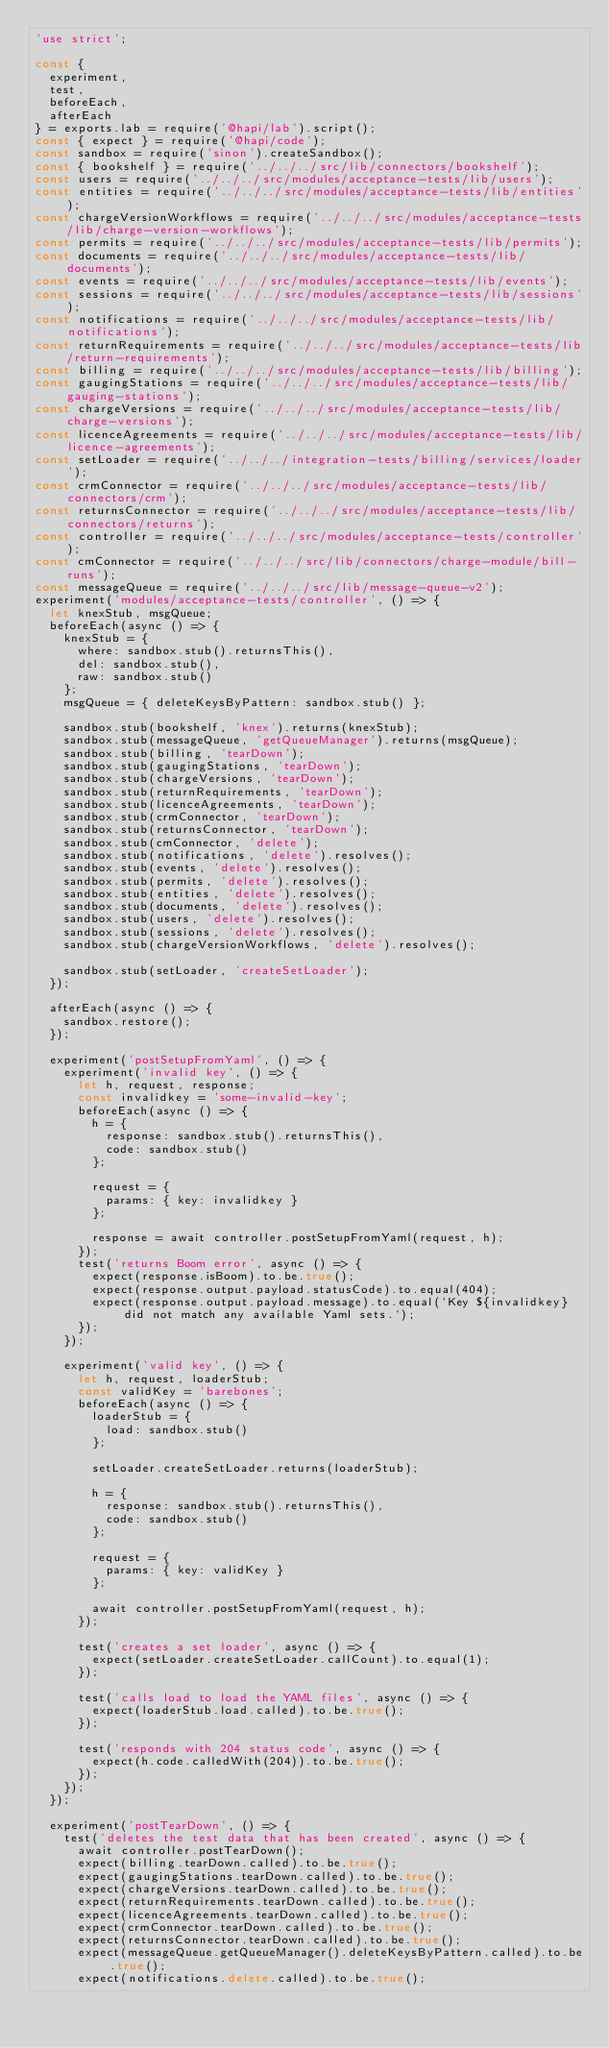Convert code to text. <code><loc_0><loc_0><loc_500><loc_500><_JavaScript_>'use strict';

const {
  experiment,
  test,
  beforeEach,
  afterEach
} = exports.lab = require('@hapi/lab').script();
const { expect } = require('@hapi/code');
const sandbox = require('sinon').createSandbox();
const { bookshelf } = require('../../../src/lib/connectors/bookshelf');
const users = require('../../../src/modules/acceptance-tests/lib/users');
const entities = require('../../../src/modules/acceptance-tests/lib/entities');
const chargeVersionWorkflows = require('../../../src/modules/acceptance-tests/lib/charge-version-workflows');
const permits = require('../../../src/modules/acceptance-tests/lib/permits');
const documents = require('../../../src/modules/acceptance-tests/lib/documents');
const events = require('../../../src/modules/acceptance-tests/lib/events');
const sessions = require('../../../src/modules/acceptance-tests/lib/sessions');
const notifications = require('../../../src/modules/acceptance-tests/lib/notifications');
const returnRequirements = require('../../../src/modules/acceptance-tests/lib/return-requirements');
const billing = require('../../../src/modules/acceptance-tests/lib/billing');
const gaugingStations = require('../../../src/modules/acceptance-tests/lib/gauging-stations');
const chargeVersions = require('../../../src/modules/acceptance-tests/lib/charge-versions');
const licenceAgreements = require('../../../src/modules/acceptance-tests/lib/licence-agreements');
const setLoader = require('../../../integration-tests/billing/services/loader');
const crmConnector = require('../../../src/modules/acceptance-tests/lib/connectors/crm');
const returnsConnector = require('../../../src/modules/acceptance-tests/lib/connectors/returns');
const controller = require('../../../src/modules/acceptance-tests/controller');
const cmConnector = require('../../../src/lib/connectors/charge-module/bill-runs');
const messageQueue = require('../../../src/lib/message-queue-v2');
experiment('modules/acceptance-tests/controller', () => {
  let knexStub, msgQueue;
  beforeEach(async () => {
    knexStub = {
      where: sandbox.stub().returnsThis(),
      del: sandbox.stub(),
      raw: sandbox.stub()
    };
    msgQueue = { deleteKeysByPattern: sandbox.stub() };

    sandbox.stub(bookshelf, 'knex').returns(knexStub);
    sandbox.stub(messageQueue, 'getQueueManager').returns(msgQueue);
    sandbox.stub(billing, 'tearDown');
    sandbox.stub(gaugingStations, 'tearDown');
    sandbox.stub(chargeVersions, 'tearDown');
    sandbox.stub(returnRequirements, 'tearDown');
    sandbox.stub(licenceAgreements, 'tearDown');
    sandbox.stub(crmConnector, 'tearDown');
    sandbox.stub(returnsConnector, 'tearDown');
    sandbox.stub(cmConnector, 'delete');
    sandbox.stub(notifications, 'delete').resolves();
    sandbox.stub(events, 'delete').resolves();
    sandbox.stub(permits, 'delete').resolves();
    sandbox.stub(entities, 'delete').resolves();
    sandbox.stub(documents, 'delete').resolves();
    sandbox.stub(users, 'delete').resolves();
    sandbox.stub(sessions, 'delete').resolves();
    sandbox.stub(chargeVersionWorkflows, 'delete').resolves();

    sandbox.stub(setLoader, 'createSetLoader');
  });

  afterEach(async () => {
    sandbox.restore();
  });

  experiment('postSetupFromYaml', () => {
    experiment('invalid key', () => {
      let h, request, response;
      const invalidkey = 'some-invalid-key';
      beforeEach(async () => {
        h = {
          response: sandbox.stub().returnsThis(),
          code: sandbox.stub()
        };

        request = {
          params: { key: invalidkey }
        };

        response = await controller.postSetupFromYaml(request, h);
      });
      test('returns Boom error', async () => {
        expect(response.isBoom).to.be.true();
        expect(response.output.payload.statusCode).to.equal(404);
        expect(response.output.payload.message).to.equal(`Key ${invalidkey} did not match any available Yaml sets.`);
      });
    });

    experiment('valid key', () => {
      let h, request, loaderStub;
      const validKey = 'barebones';
      beforeEach(async () => {
        loaderStub = {
          load: sandbox.stub()
        };

        setLoader.createSetLoader.returns(loaderStub);

        h = {
          response: sandbox.stub().returnsThis(),
          code: sandbox.stub()
        };

        request = {
          params: { key: validKey }
        };

        await controller.postSetupFromYaml(request, h);
      });

      test('creates a set loader', async () => {
        expect(setLoader.createSetLoader.callCount).to.equal(1);
      });

      test('calls load to load the YAML files', async () => {
        expect(loaderStub.load.called).to.be.true();
      });

      test('responds with 204 status code', async () => {
        expect(h.code.calledWith(204)).to.be.true();
      });
    });
  });

  experiment('postTearDown', () => {
    test('deletes the test data that has been created', async () => {
      await controller.postTearDown();
      expect(billing.tearDown.called).to.be.true();
      expect(gaugingStations.tearDown.called).to.be.true();
      expect(chargeVersions.tearDown.called).to.be.true();
      expect(returnRequirements.tearDown.called).to.be.true();
      expect(licenceAgreements.tearDown.called).to.be.true();
      expect(crmConnector.tearDown.called).to.be.true();
      expect(returnsConnector.tearDown.called).to.be.true();
      expect(messageQueue.getQueueManager().deleteKeysByPattern.called).to.be.true();
      expect(notifications.delete.called).to.be.true();</code> 